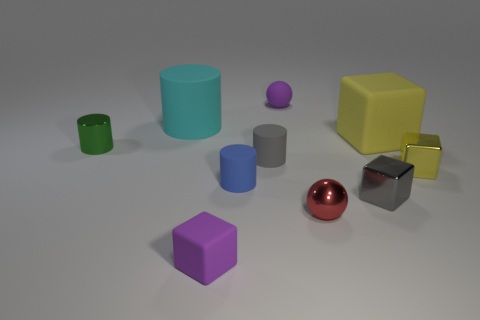Subtract 1 cylinders. How many cylinders are left? 3 Subtract all gray cubes. How many cubes are left? 3 Subtract all brown cylinders. Subtract all gray balls. How many cylinders are left? 4 Subtract all cylinders. How many objects are left? 6 Subtract all red spheres. Subtract all rubber cubes. How many objects are left? 7 Add 2 blue things. How many blue things are left? 3 Add 4 tiny yellow metal cylinders. How many tiny yellow metal cylinders exist? 4 Subtract 0 cyan spheres. How many objects are left? 10 